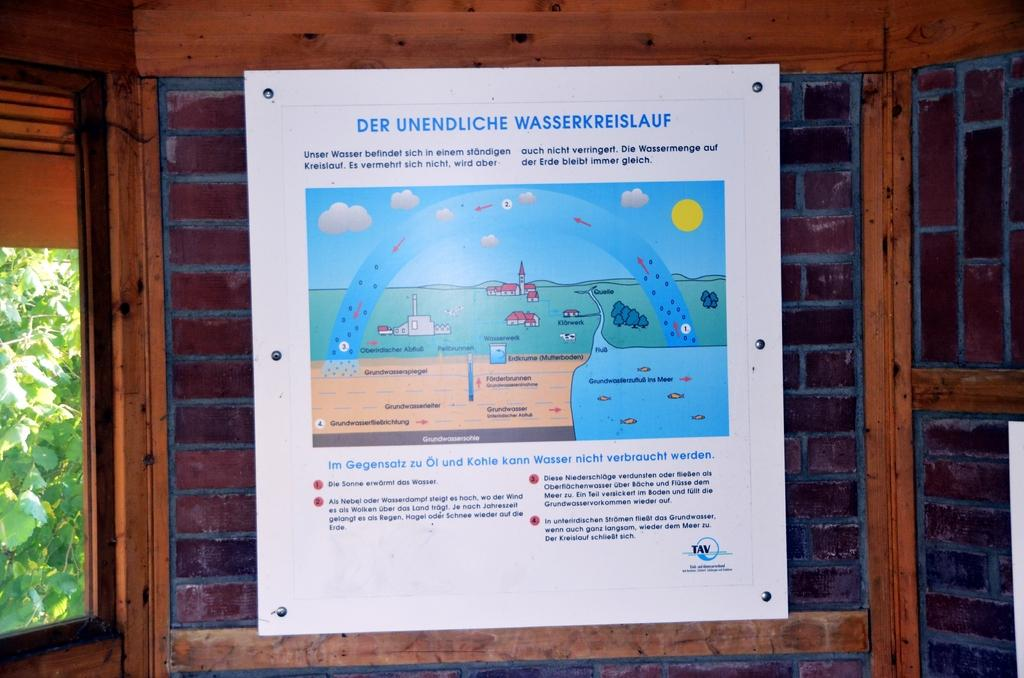What is located in the foreground of the image? There is a poster in the foreground of the image. What can be seen on the poster? The poster has text and an image on it. What is visible in the background of the image? There is a window, trees, and a wall visible in the background of the image. How do the dogs react to the payment in the image? There are no dogs or payment present in the image. 